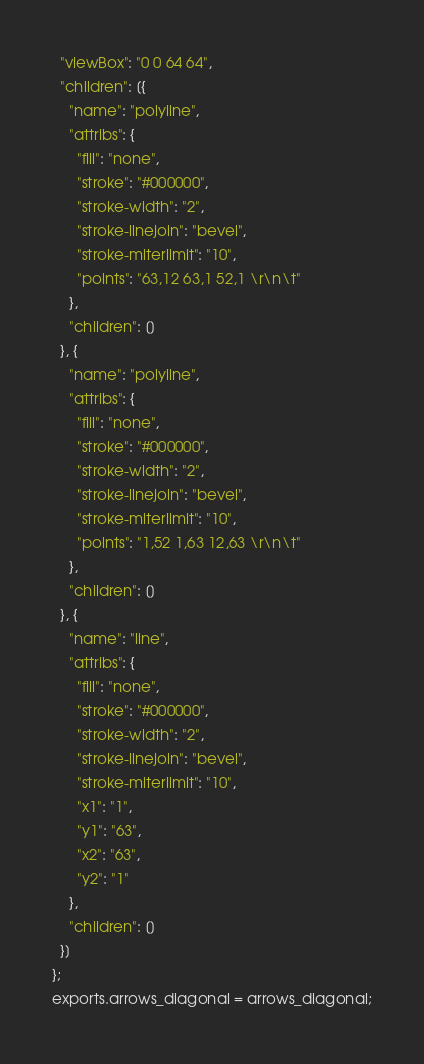Convert code to text. <code><loc_0><loc_0><loc_500><loc_500><_JavaScript_>  "viewBox": "0 0 64 64",
  "children": [{
    "name": "polyline",
    "attribs": {
      "fill": "none",
      "stroke": "#000000",
      "stroke-width": "2",
      "stroke-linejoin": "bevel",
      "stroke-miterlimit": "10",
      "points": "63,12 63,1 52,1 \r\n\t"
    },
    "children": []
  }, {
    "name": "polyline",
    "attribs": {
      "fill": "none",
      "stroke": "#000000",
      "stroke-width": "2",
      "stroke-linejoin": "bevel",
      "stroke-miterlimit": "10",
      "points": "1,52 1,63 12,63 \r\n\t"
    },
    "children": []
  }, {
    "name": "line",
    "attribs": {
      "fill": "none",
      "stroke": "#000000",
      "stroke-width": "2",
      "stroke-linejoin": "bevel",
      "stroke-miterlimit": "10",
      "x1": "1",
      "y1": "63",
      "x2": "63",
      "y2": "1"
    },
    "children": []
  }]
};
exports.arrows_diagonal = arrows_diagonal;</code> 